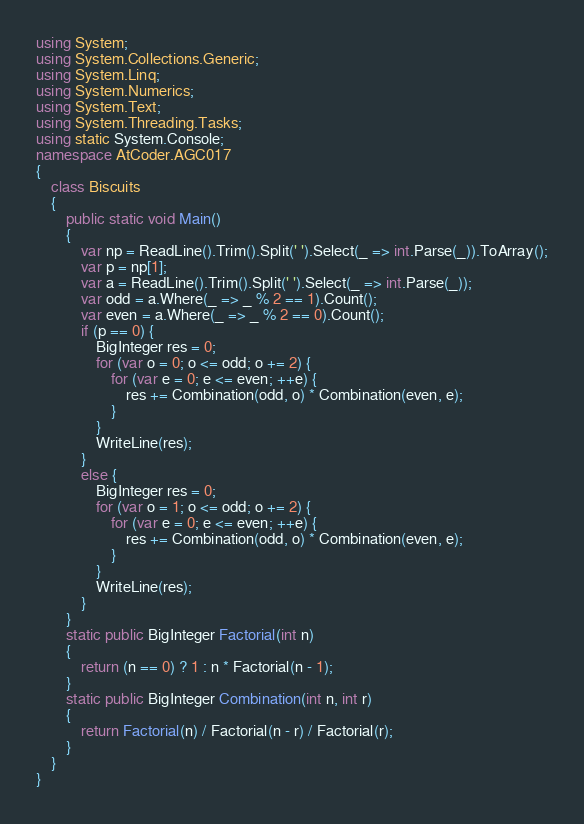Convert code to text. <code><loc_0><loc_0><loc_500><loc_500><_C#_>using System;
using System.Collections.Generic;
using System.Linq;
using System.Numerics;
using System.Text;
using System.Threading.Tasks;
using static System.Console;
namespace AtCoder.AGC017
{
    class Biscuits
    {
        public static void Main()
        {
            var np = ReadLine().Trim().Split(' ').Select(_ => int.Parse(_)).ToArray();
            var p = np[1];
            var a = ReadLine().Trim().Split(' ').Select(_ => int.Parse(_));
            var odd = a.Where(_ => _ % 2 == 1).Count();
            var even = a.Where(_ => _ % 2 == 0).Count();
            if (p == 0) {
                BigInteger res = 0;
                for (var o = 0; o <= odd; o += 2) {
                    for (var e = 0; e <= even; ++e) {
                        res += Combination(odd, o) * Combination(even, e);
                    }
                }
                WriteLine(res);
            }
            else {
                BigInteger res = 0;
                for (var o = 1; o <= odd; o += 2) {
                    for (var e = 0; e <= even; ++e) {
                        res += Combination(odd, o) * Combination(even, e);
                    }
                }
                WriteLine(res);
            }
        }
        static public BigInteger Factorial(int n)
        {
            return (n == 0) ? 1 : n * Factorial(n - 1);
        }
        static public BigInteger Combination(int n, int r)
        {
            return Factorial(n) / Factorial(n - r) / Factorial(r);
        }
    }
}
</code> 